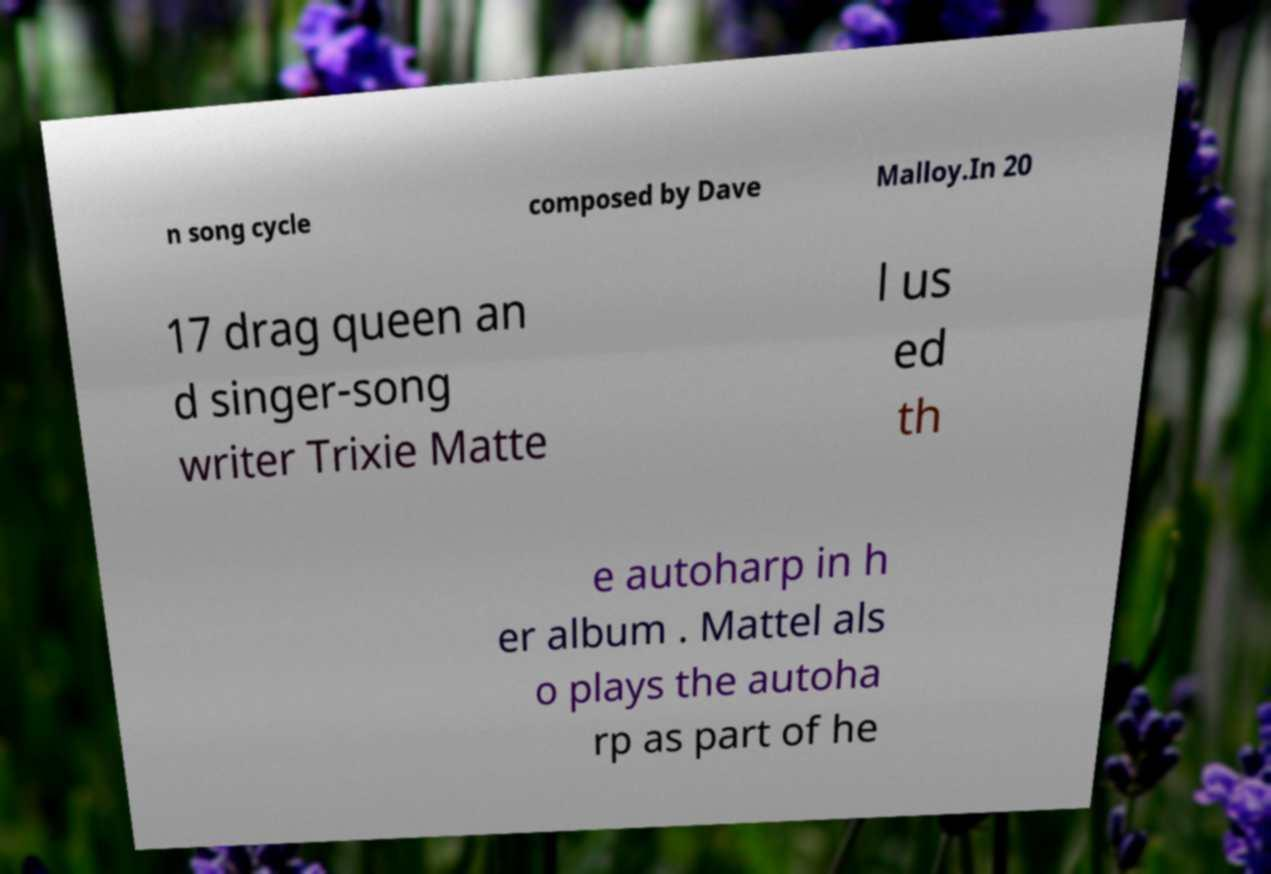Can you read and provide the text displayed in the image?This photo seems to have some interesting text. Can you extract and type it out for me? n song cycle composed by Dave Malloy.In 20 17 drag queen an d singer-song writer Trixie Matte l us ed th e autoharp in h er album . Mattel als o plays the autoha rp as part of he 